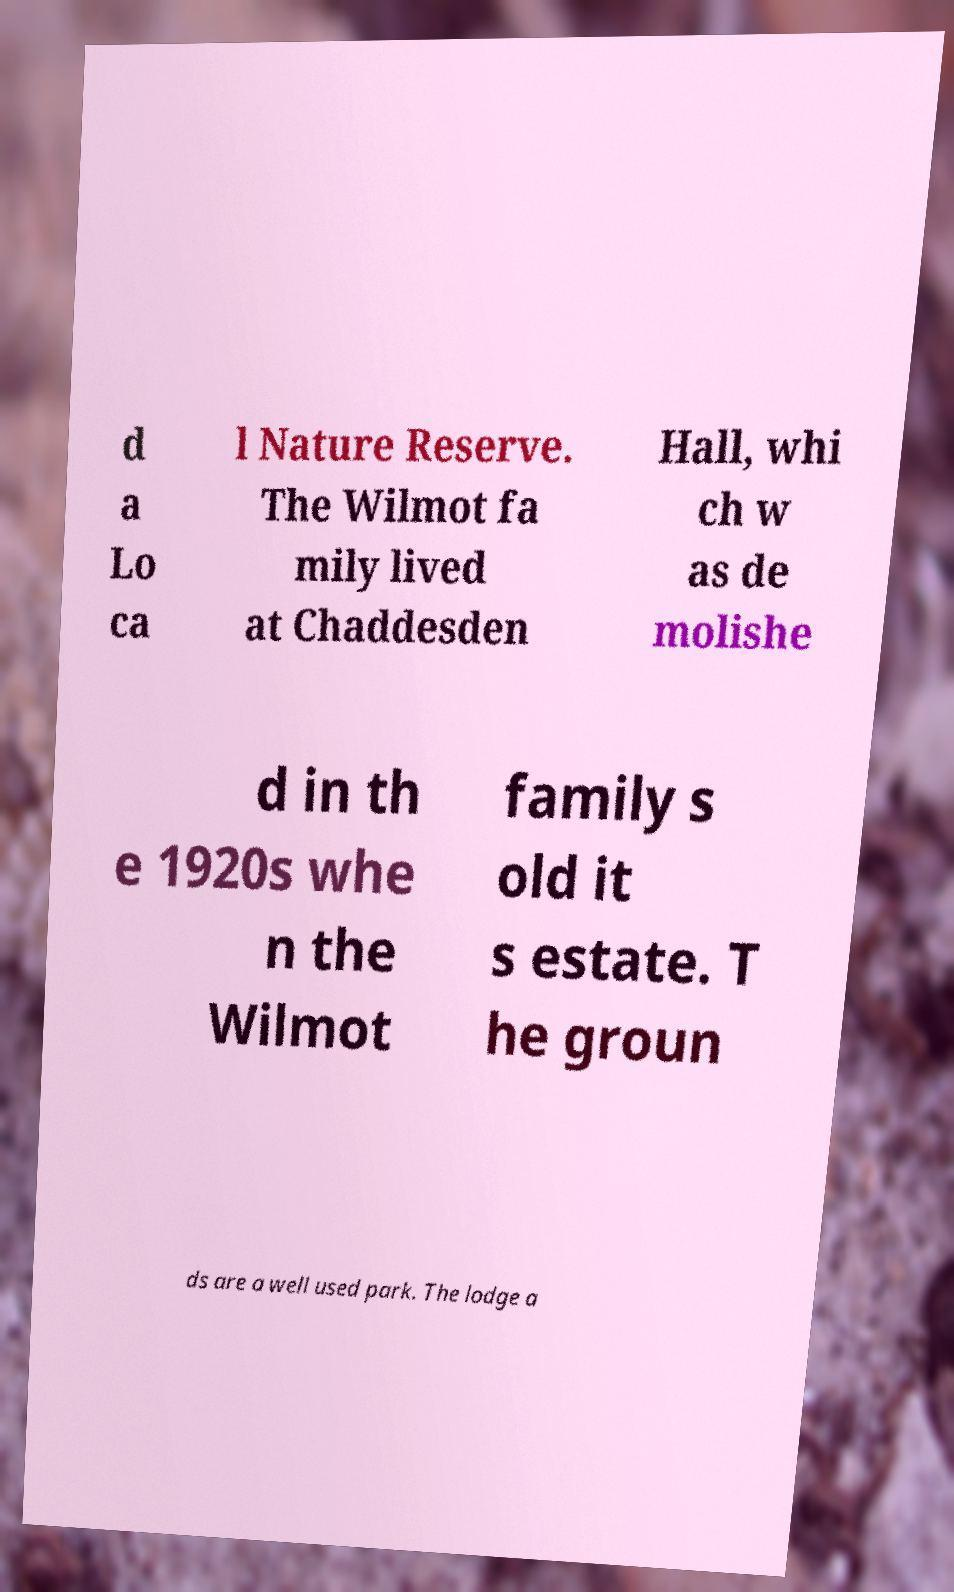Can you accurately transcribe the text from the provided image for me? d a Lo ca l Nature Reserve. The Wilmot fa mily lived at Chaddesden Hall, whi ch w as de molishe d in th e 1920s whe n the Wilmot family s old it s estate. T he groun ds are a well used park. The lodge a 